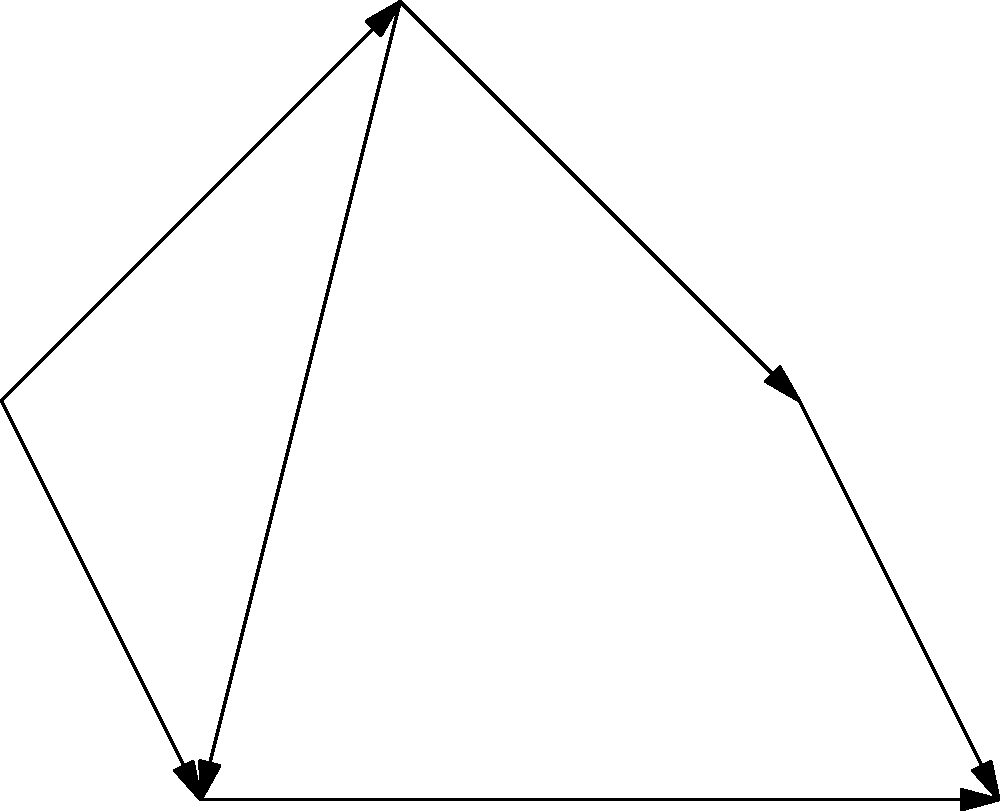As a videographer covering an event, you need to navigate between five shooting locations ($L_1$ to $L_5$) in an event space. The graph represents the possible paths between locations, with edges indicating direct connections and their associated travel times in minutes. Starting from location $L_1$, what is the shortest time (in minutes) required to reach location $L_5$? To find the shortest path from $L_1$ to $L_5$, we can use Dijkstra's algorithm:

1) Initialize:
   - Distance to $L_1$ = 0
   - Distance to all other nodes = $\infty$

2) Start from $L_1$:
   - Update neighbors: $L_2$ (5 min), $L_4$ (3 min)

3) Choose the closest unvisited node: $L_4$ (3 min)
   - Update neighbors: $L_5$ (3 + 7 = 10 min)

4) Choose the next closest unvisited node: $L_2$ (5 min)
   - Update neighbors: $L_3$ (5 + 4 = 9 min), $L_4$ (5 + 2 = 7 min, no improvement)

5) Choose the next closest unvisited node: $L_3$ (9 min)
   - Update neighbors: $L_5$ (9 + 6 = 15 min, no improvement)

6) $L_5$ is the only unvisited node left, and its shortest distance is 10 minutes.

Therefore, the shortest path from $L_1$ to $L_5$ is $L_1 \rightarrow L_4 \rightarrow L_5$, taking 10 minutes.
Answer: 10 minutes 